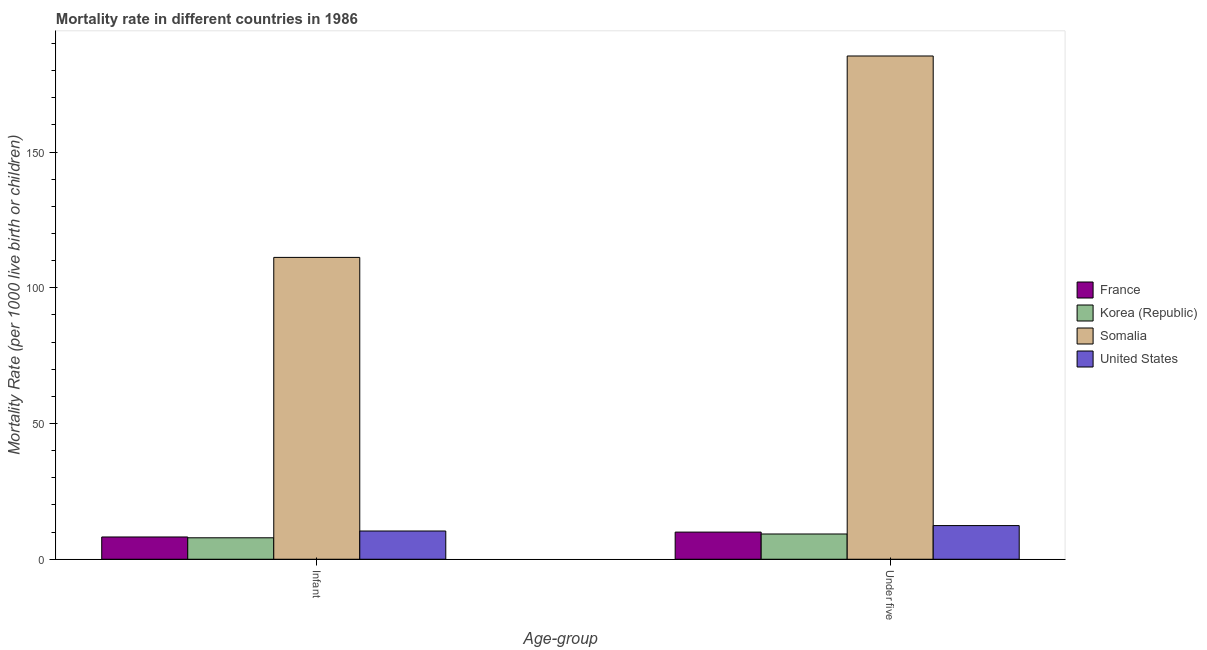Are the number of bars on each tick of the X-axis equal?
Keep it short and to the point. Yes. How many bars are there on the 2nd tick from the left?
Give a very brief answer. 4. How many bars are there on the 1st tick from the right?
Make the answer very short. 4. What is the label of the 1st group of bars from the left?
Make the answer very short. Infant. Across all countries, what is the maximum under-5 mortality rate?
Your answer should be compact. 185.4. In which country was the under-5 mortality rate maximum?
Ensure brevity in your answer.  Somalia. In which country was the under-5 mortality rate minimum?
Provide a succinct answer. Korea (Republic). What is the total under-5 mortality rate in the graph?
Offer a terse response. 217.1. What is the difference between the infant mortality rate in Somalia and that in United States?
Give a very brief answer. 100.8. What is the difference between the infant mortality rate in Somalia and the under-5 mortality rate in Korea (Republic)?
Keep it short and to the point. 101.9. What is the average infant mortality rate per country?
Provide a succinct answer. 34.43. What is the difference between the infant mortality rate and under-5 mortality rate in Somalia?
Your answer should be very brief. -74.2. What is the ratio of the under-5 mortality rate in France to that in Somalia?
Make the answer very short. 0.05. Is the infant mortality rate in Somalia less than that in United States?
Give a very brief answer. No. Are the values on the major ticks of Y-axis written in scientific E-notation?
Provide a succinct answer. No. Does the graph contain any zero values?
Offer a very short reply. No. What is the title of the graph?
Ensure brevity in your answer.  Mortality rate in different countries in 1986. Does "Nepal" appear as one of the legend labels in the graph?
Provide a short and direct response. No. What is the label or title of the X-axis?
Your answer should be compact. Age-group. What is the label or title of the Y-axis?
Give a very brief answer. Mortality Rate (per 1000 live birth or children). What is the Mortality Rate (per 1000 live birth or children) of France in Infant?
Provide a succinct answer. 8.2. What is the Mortality Rate (per 1000 live birth or children) in Somalia in Infant?
Give a very brief answer. 111.2. What is the Mortality Rate (per 1000 live birth or children) in United States in Infant?
Keep it short and to the point. 10.4. What is the Mortality Rate (per 1000 live birth or children) of France in Under five?
Offer a terse response. 10. What is the Mortality Rate (per 1000 live birth or children) in Korea (Republic) in Under five?
Provide a short and direct response. 9.3. What is the Mortality Rate (per 1000 live birth or children) in Somalia in Under five?
Give a very brief answer. 185.4. Across all Age-group, what is the maximum Mortality Rate (per 1000 live birth or children) in Somalia?
Offer a terse response. 185.4. Across all Age-group, what is the minimum Mortality Rate (per 1000 live birth or children) of Somalia?
Give a very brief answer. 111.2. Across all Age-group, what is the minimum Mortality Rate (per 1000 live birth or children) in United States?
Provide a short and direct response. 10.4. What is the total Mortality Rate (per 1000 live birth or children) of France in the graph?
Your response must be concise. 18.2. What is the total Mortality Rate (per 1000 live birth or children) of Korea (Republic) in the graph?
Keep it short and to the point. 17.2. What is the total Mortality Rate (per 1000 live birth or children) in Somalia in the graph?
Keep it short and to the point. 296.6. What is the total Mortality Rate (per 1000 live birth or children) of United States in the graph?
Your answer should be compact. 22.8. What is the difference between the Mortality Rate (per 1000 live birth or children) in France in Infant and that in Under five?
Provide a succinct answer. -1.8. What is the difference between the Mortality Rate (per 1000 live birth or children) of Korea (Republic) in Infant and that in Under five?
Keep it short and to the point. -1.4. What is the difference between the Mortality Rate (per 1000 live birth or children) of Somalia in Infant and that in Under five?
Offer a terse response. -74.2. What is the difference between the Mortality Rate (per 1000 live birth or children) of France in Infant and the Mortality Rate (per 1000 live birth or children) of Korea (Republic) in Under five?
Offer a terse response. -1.1. What is the difference between the Mortality Rate (per 1000 live birth or children) of France in Infant and the Mortality Rate (per 1000 live birth or children) of Somalia in Under five?
Give a very brief answer. -177.2. What is the difference between the Mortality Rate (per 1000 live birth or children) of Korea (Republic) in Infant and the Mortality Rate (per 1000 live birth or children) of Somalia in Under five?
Provide a short and direct response. -177.5. What is the difference between the Mortality Rate (per 1000 live birth or children) in Somalia in Infant and the Mortality Rate (per 1000 live birth or children) in United States in Under five?
Ensure brevity in your answer.  98.8. What is the average Mortality Rate (per 1000 live birth or children) in France per Age-group?
Provide a succinct answer. 9.1. What is the average Mortality Rate (per 1000 live birth or children) in Korea (Republic) per Age-group?
Your answer should be compact. 8.6. What is the average Mortality Rate (per 1000 live birth or children) of Somalia per Age-group?
Your response must be concise. 148.3. What is the difference between the Mortality Rate (per 1000 live birth or children) of France and Mortality Rate (per 1000 live birth or children) of Somalia in Infant?
Give a very brief answer. -103. What is the difference between the Mortality Rate (per 1000 live birth or children) of France and Mortality Rate (per 1000 live birth or children) of United States in Infant?
Offer a terse response. -2.2. What is the difference between the Mortality Rate (per 1000 live birth or children) of Korea (Republic) and Mortality Rate (per 1000 live birth or children) of Somalia in Infant?
Your answer should be very brief. -103.3. What is the difference between the Mortality Rate (per 1000 live birth or children) of Korea (Republic) and Mortality Rate (per 1000 live birth or children) of United States in Infant?
Provide a succinct answer. -2.5. What is the difference between the Mortality Rate (per 1000 live birth or children) of Somalia and Mortality Rate (per 1000 live birth or children) of United States in Infant?
Your answer should be very brief. 100.8. What is the difference between the Mortality Rate (per 1000 live birth or children) of France and Mortality Rate (per 1000 live birth or children) of Korea (Republic) in Under five?
Provide a succinct answer. 0.7. What is the difference between the Mortality Rate (per 1000 live birth or children) in France and Mortality Rate (per 1000 live birth or children) in Somalia in Under five?
Offer a very short reply. -175.4. What is the difference between the Mortality Rate (per 1000 live birth or children) of Korea (Republic) and Mortality Rate (per 1000 live birth or children) of Somalia in Under five?
Your response must be concise. -176.1. What is the difference between the Mortality Rate (per 1000 live birth or children) in Somalia and Mortality Rate (per 1000 live birth or children) in United States in Under five?
Your answer should be compact. 173. What is the ratio of the Mortality Rate (per 1000 live birth or children) of France in Infant to that in Under five?
Give a very brief answer. 0.82. What is the ratio of the Mortality Rate (per 1000 live birth or children) of Korea (Republic) in Infant to that in Under five?
Offer a very short reply. 0.85. What is the ratio of the Mortality Rate (per 1000 live birth or children) of Somalia in Infant to that in Under five?
Ensure brevity in your answer.  0.6. What is the ratio of the Mortality Rate (per 1000 live birth or children) in United States in Infant to that in Under five?
Your answer should be compact. 0.84. What is the difference between the highest and the second highest Mortality Rate (per 1000 live birth or children) of Somalia?
Make the answer very short. 74.2. What is the difference between the highest and the second highest Mortality Rate (per 1000 live birth or children) of United States?
Your response must be concise. 2. What is the difference between the highest and the lowest Mortality Rate (per 1000 live birth or children) in France?
Your response must be concise. 1.8. What is the difference between the highest and the lowest Mortality Rate (per 1000 live birth or children) of Somalia?
Keep it short and to the point. 74.2. 